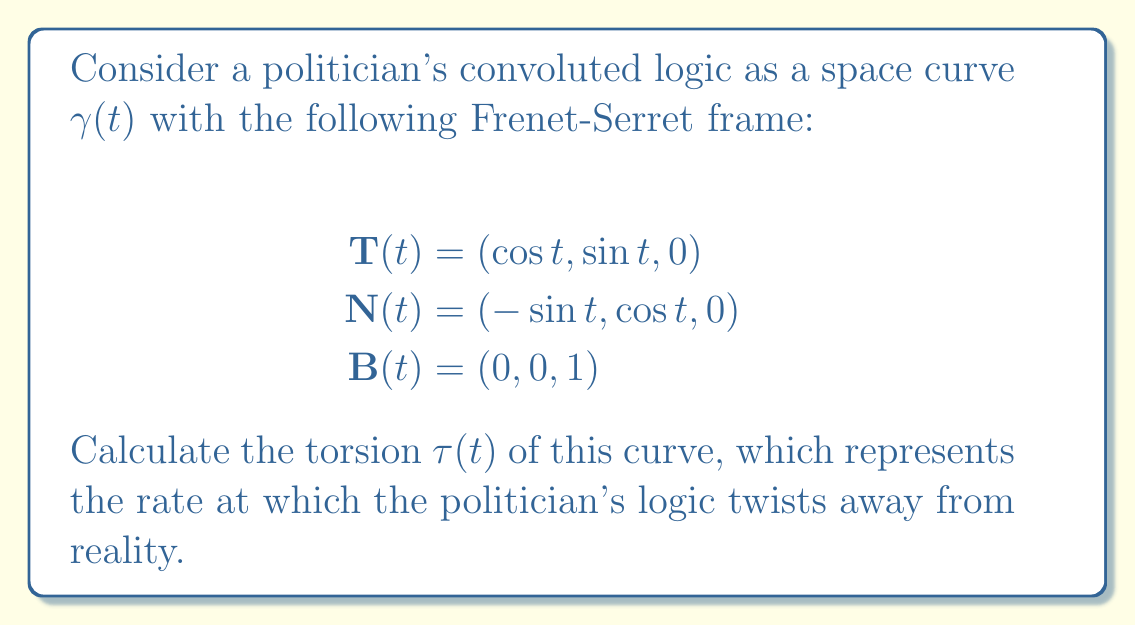Can you answer this question? To find the torsion $\tau(t)$ of the curve, we'll use the Frenet-Serret formulas:

1) Recall that the Frenet-Serret formulas state:
   $$\frac{d\mathbf{T}}{dt} = \kappa \mathbf{N}$$
   $$\frac{d\mathbf{N}}{dt} = -\kappa \mathbf{T} + \tau \mathbf{B}$$
   $$\frac{d\mathbf{B}}{dt} = -\tau \mathbf{N}$$

2) We're interested in finding $\tau$, which appears in the equation for $\frac{d\mathbf{B}}{dt}$.

3) Given $\mathbf{B}(t) = (0, 0, 1)$, we can see that $\frac{d\mathbf{B}}{dt} = (0, 0, 0)$.

4) Substituting this into the third Frenet-Serret formula:
   $$(0, 0, 0) = -\tau \mathbf{N}$$

5) Since $\mathbf{N}(t) = (-\sin t, \cos t, 0)$ is non-zero, the only way for this equation to be true is if $\tau = 0$.

6) This means the torsion of the curve is zero for all $t$.
Answer: $\tau(t) = 0$ 